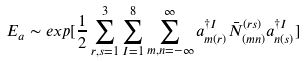Convert formula to latex. <formula><loc_0><loc_0><loc_500><loc_500>E _ { a } \sim e x p [ \frac { 1 } { 2 } \sum _ { r , s = 1 } ^ { 3 } \sum _ { I = 1 } ^ { 8 } \sum _ { m , n = - \infty } ^ { \infty } a _ { m ( r ) } ^ { \dagger I } \bar { N } _ { ( m n ) } ^ { ( r s ) } a _ { n ( s ) } ^ { \dagger I } ]</formula> 